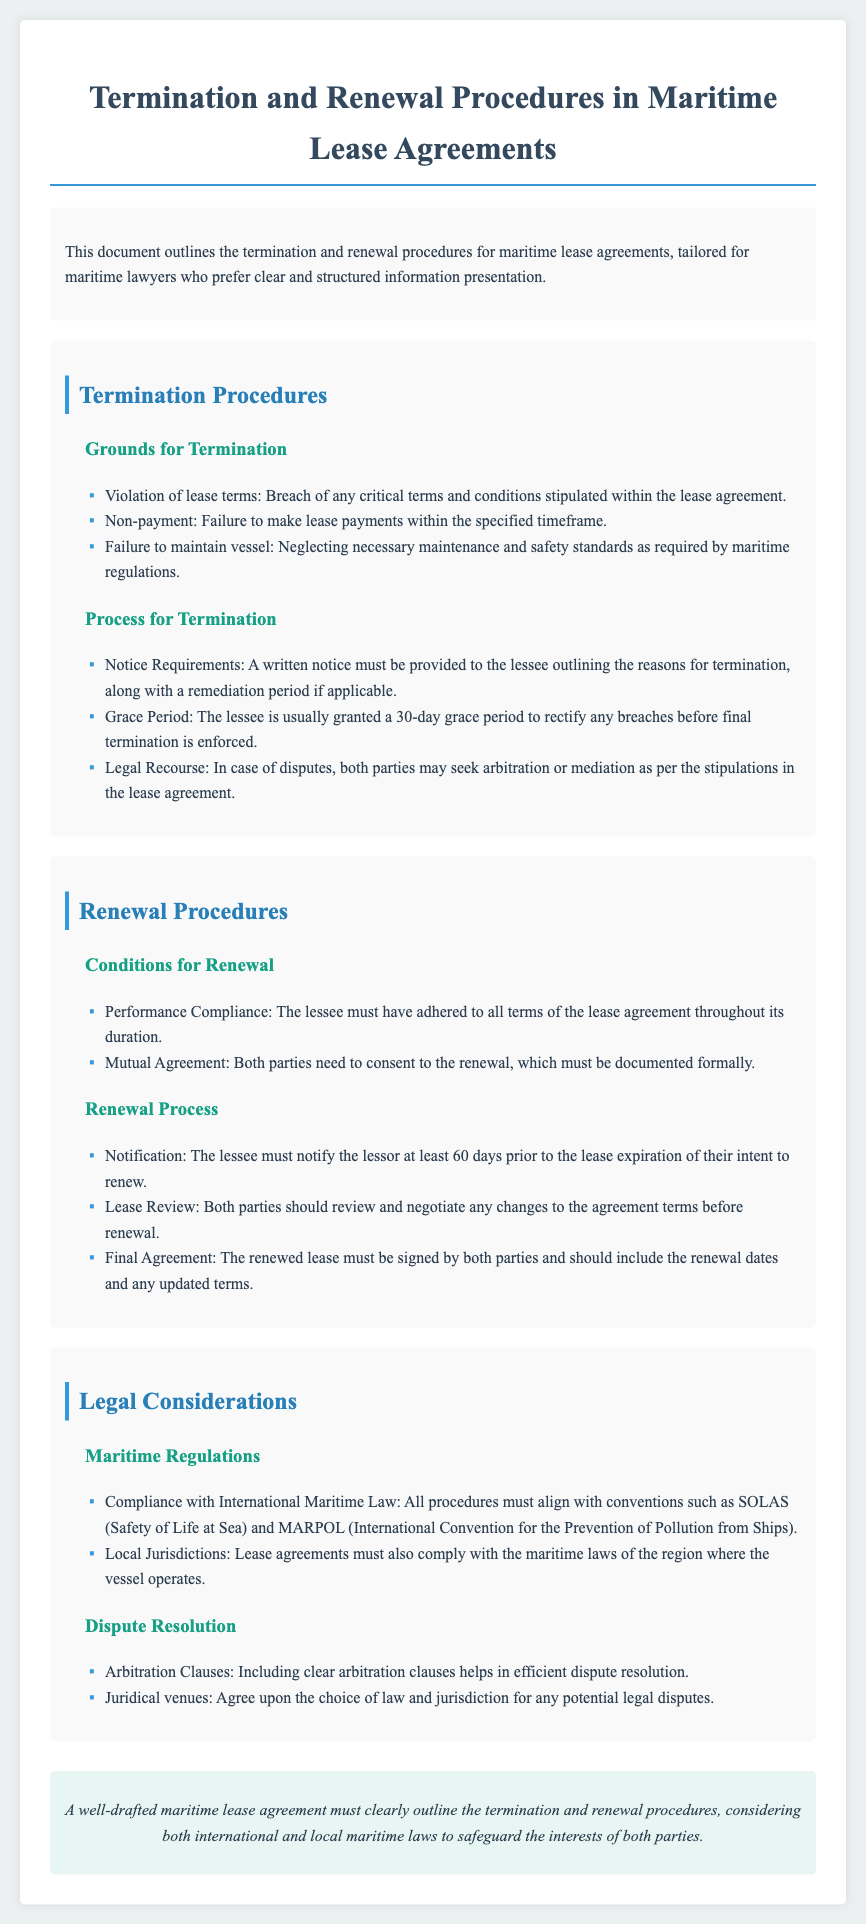What are the grounds for termination? The grounds for termination include violation of lease terms, non-payment, and failure to maintain vessel as required by maritime regulations.
Answer: Violation of lease terms, non-payment, failure to maintain vessel What is the grace period for rectifying breaches? The document specifies that the lessee is usually granted a 30-day grace period to rectify any breaches before final termination is enforced.
Answer: 30 days How long before lease expiration must the lessee notify the lessor of intent to renew? According to the renewal process, the lessee must notify the lessor at least 60 days prior to lease expiration of their intent to renew.
Answer: 60 days What maritime regulations must be complied with? The document mentions compliance with International Maritime Law, specifically conventions such as SOLAS and MARPOL.
Answer: SOLAS, MARPOL What is required for a renewal to take place? The conditions for renewal include performance compliance and mutual agreement documented formally.
Answer: Performance compliance, mutual agreement 